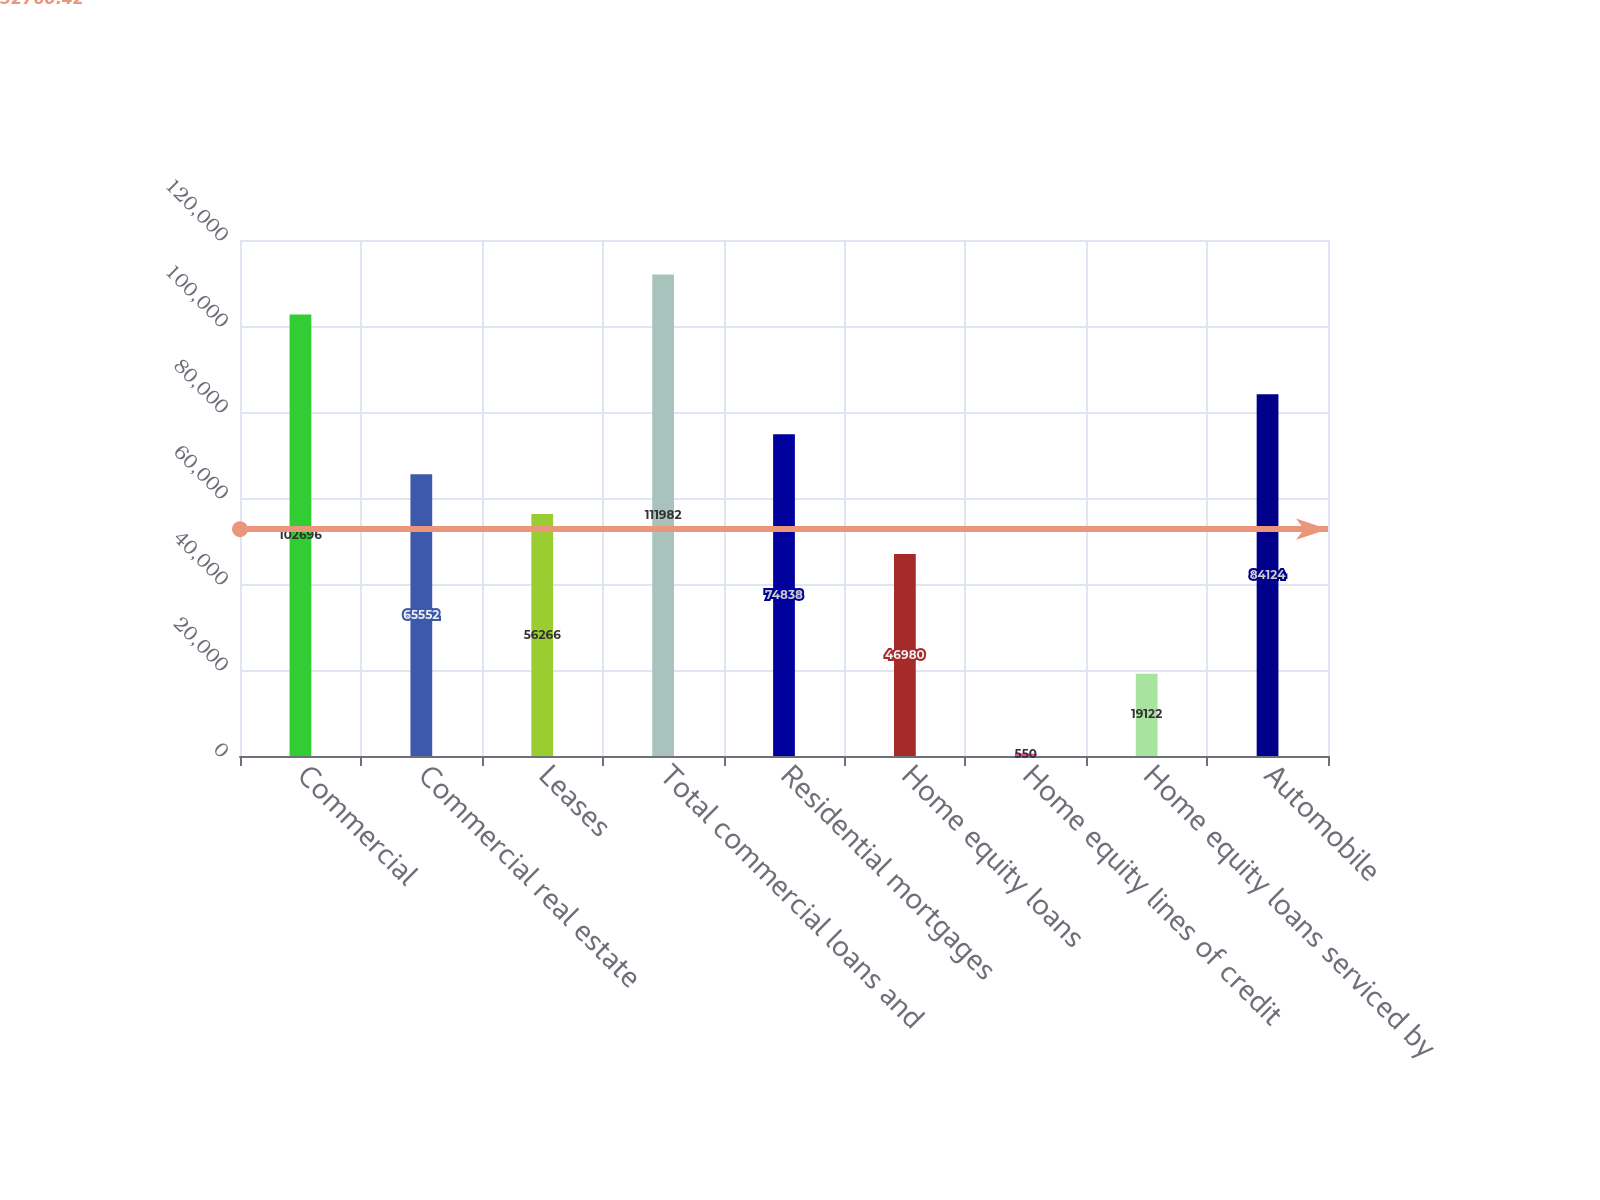Convert chart. <chart><loc_0><loc_0><loc_500><loc_500><bar_chart><fcel>Commercial<fcel>Commercial real estate<fcel>Leases<fcel>Total commercial loans and<fcel>Residential mortgages<fcel>Home equity loans<fcel>Home equity lines of credit<fcel>Home equity loans serviced by<fcel>Automobile<nl><fcel>102696<fcel>65552<fcel>56266<fcel>111982<fcel>74838<fcel>46980<fcel>550<fcel>19122<fcel>84124<nl></chart> 